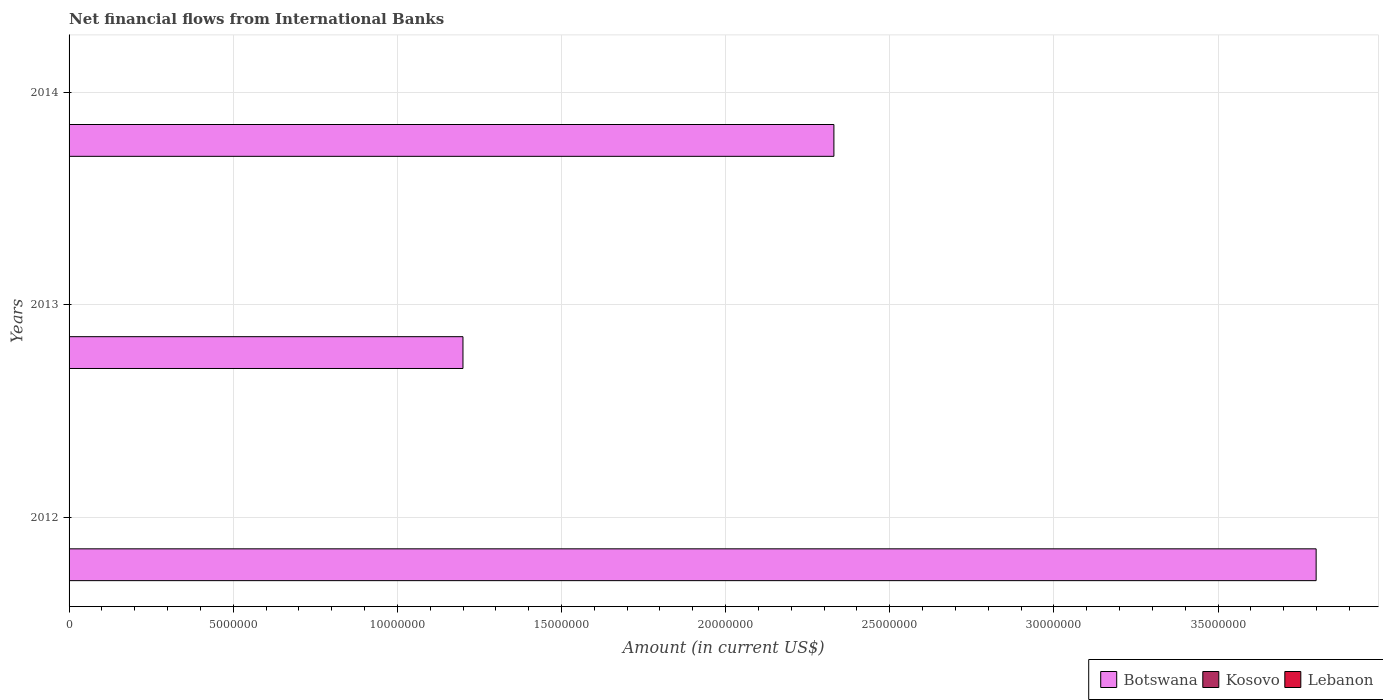Are the number of bars per tick equal to the number of legend labels?
Provide a short and direct response. No. Are the number of bars on each tick of the Y-axis equal?
Your answer should be compact. Yes. What is the net financial aid flows in Kosovo in 2012?
Provide a succinct answer. 0. Across all years, what is the maximum net financial aid flows in Botswana?
Offer a terse response. 3.80e+07. Across all years, what is the minimum net financial aid flows in Kosovo?
Keep it short and to the point. 0. What is the total net financial aid flows in Kosovo in the graph?
Give a very brief answer. 0. What is the difference between the net financial aid flows in Botswana in 2013 and that in 2014?
Provide a short and direct response. -1.13e+07. What is the difference between the net financial aid flows in Lebanon in 2014 and the net financial aid flows in Botswana in 2013?
Give a very brief answer. -1.20e+07. What is the average net financial aid flows in Botswana per year?
Ensure brevity in your answer.  2.44e+07. What is the ratio of the net financial aid flows in Botswana in 2012 to that in 2013?
Provide a succinct answer. 3.17. What is the difference between the highest and the second highest net financial aid flows in Botswana?
Make the answer very short. 1.47e+07. How many years are there in the graph?
Offer a very short reply. 3. What is the difference between two consecutive major ticks on the X-axis?
Offer a terse response. 5.00e+06. Are the values on the major ticks of X-axis written in scientific E-notation?
Offer a very short reply. No. Does the graph contain any zero values?
Make the answer very short. Yes. How many legend labels are there?
Provide a short and direct response. 3. What is the title of the graph?
Your response must be concise. Net financial flows from International Banks. Does "Burkina Faso" appear as one of the legend labels in the graph?
Ensure brevity in your answer.  No. What is the label or title of the X-axis?
Your response must be concise. Amount (in current US$). What is the Amount (in current US$) in Botswana in 2012?
Your answer should be compact. 3.80e+07. What is the Amount (in current US$) of Botswana in 2013?
Your answer should be compact. 1.20e+07. What is the Amount (in current US$) of Lebanon in 2013?
Offer a terse response. 0. What is the Amount (in current US$) of Botswana in 2014?
Make the answer very short. 2.33e+07. What is the Amount (in current US$) in Lebanon in 2014?
Offer a very short reply. 0. Across all years, what is the maximum Amount (in current US$) in Botswana?
Provide a short and direct response. 3.80e+07. Across all years, what is the minimum Amount (in current US$) in Botswana?
Make the answer very short. 1.20e+07. What is the total Amount (in current US$) in Botswana in the graph?
Provide a short and direct response. 7.33e+07. What is the difference between the Amount (in current US$) in Botswana in 2012 and that in 2013?
Provide a short and direct response. 2.60e+07. What is the difference between the Amount (in current US$) of Botswana in 2012 and that in 2014?
Give a very brief answer. 1.47e+07. What is the difference between the Amount (in current US$) in Botswana in 2013 and that in 2014?
Offer a terse response. -1.13e+07. What is the average Amount (in current US$) in Botswana per year?
Offer a terse response. 2.44e+07. What is the average Amount (in current US$) of Kosovo per year?
Your answer should be very brief. 0. What is the average Amount (in current US$) in Lebanon per year?
Offer a very short reply. 0. What is the ratio of the Amount (in current US$) in Botswana in 2012 to that in 2013?
Provide a short and direct response. 3.17. What is the ratio of the Amount (in current US$) of Botswana in 2012 to that in 2014?
Your answer should be very brief. 1.63. What is the ratio of the Amount (in current US$) in Botswana in 2013 to that in 2014?
Your response must be concise. 0.52. What is the difference between the highest and the second highest Amount (in current US$) in Botswana?
Give a very brief answer. 1.47e+07. What is the difference between the highest and the lowest Amount (in current US$) of Botswana?
Make the answer very short. 2.60e+07. 